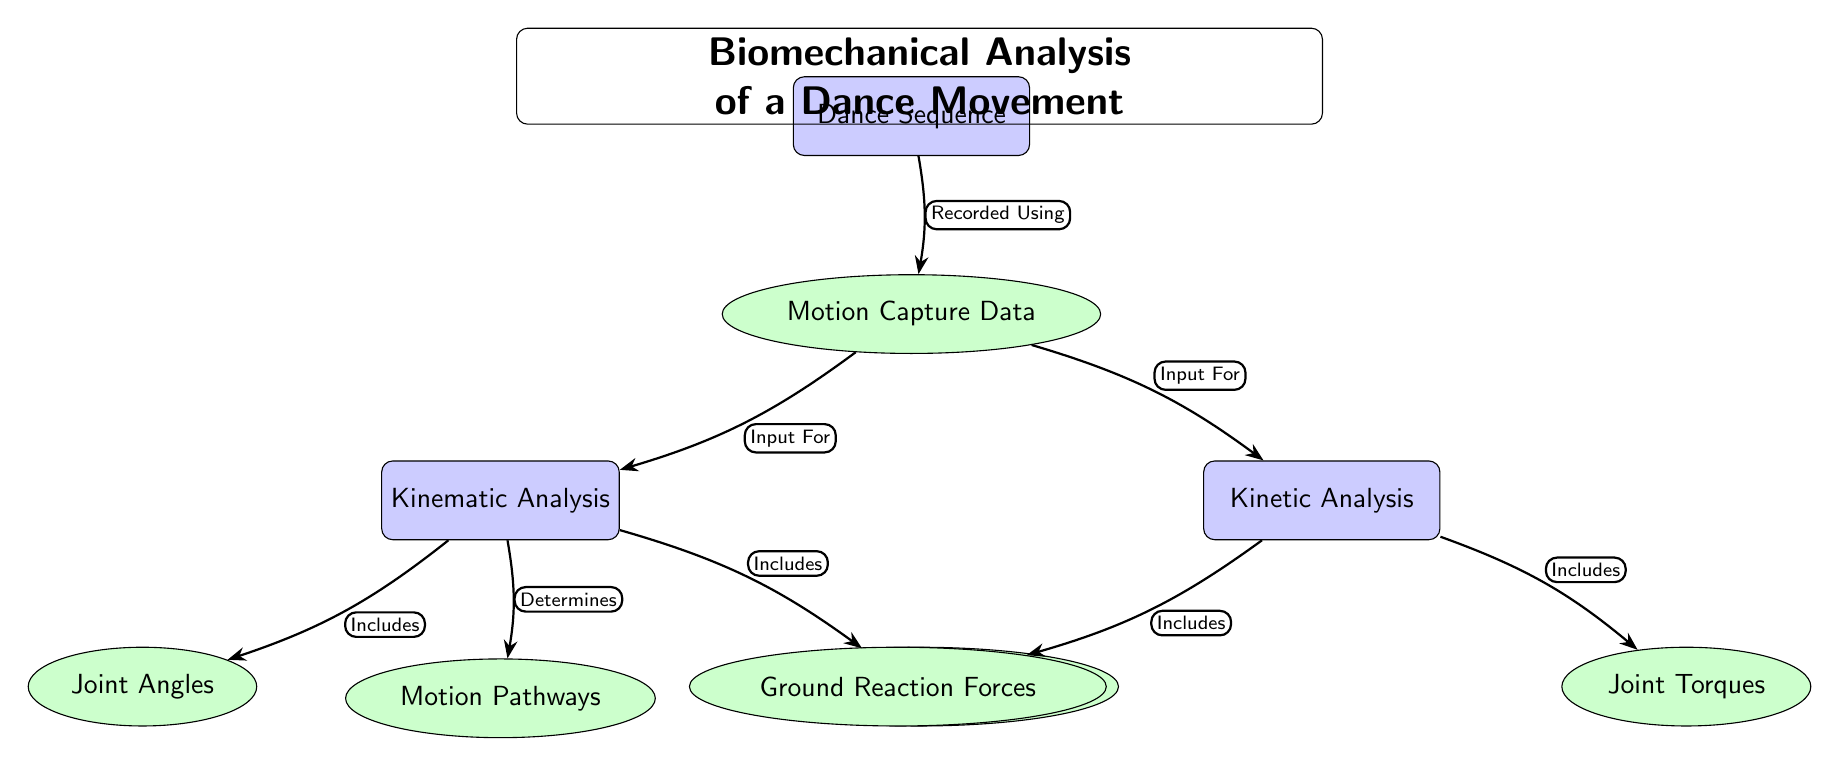What is the main subject of the diagram? The main subject is indicated at the top of the diagram where it states “Biomechanical Analysis of a Dance Movement.” This identifies the primary focus of the diagram.
Answer: Biomechanical Analysis of a Dance Movement How many main nodes are there in the diagram? By counting the nodes marked as "main" (rectangles) in the diagram, there are three main nodes: "Dance Sequence," "Kinematic Analysis," and "Kinetic Analysis."
Answer: 3 What section includes "Joint Angles"? "Joint Angles" is listed as a sub-node connected to the "Kinematic Analysis" node with the label “Includes.” This shows that it is part of the kinematic analysis section.
Answer: Kinematic Analysis What does the "Motion Capture Data" connect to? The node "Motion Capture Data" connects to two main nodes: "Kinematic Analysis" and "Kinetic Analysis," as indicated by the arrows labeled “Input For.” This defines its role as an input for both types of analysis.
Answer: Kinematic Analysis and Kinetic Analysis What is determined from the "Kinematic Analysis"? The "Kinematic Analysis" node indicates it “Determines” the "Motion Pathways," showing that the analysis of kinematics results in understanding the pathways of motion involved in the dance.
Answer: Motion Pathways Which element is related to "Ground Reaction Forces"? The "Ground Reaction Forces" are part of the "Kinetic Analysis," as indicated by the inclusion relationship shown by the arrow labeled “Includes.” This highlights that ground reaction forces are analyzed under kinetic analysis.
Answer: Kinetic Analysis What is the relationship between "Dance Sequence" and "Motion Capture Data"? "Dance Sequence" leads to "Motion Capture Data" with the connection labeled “Recorded Using,” indicating that the motion capture data is recorded from the dance sequence.
Answer: Recorded Using What type of analysis includes "Joint Torques"? The "Joint Torques" element is included in the "Kinetic Analysis," as shown by the arrow labeled “Includes.” This clarifies that joint torques are a component of kinetic factors in the analysis.
Answer: Kinetic Analysis 